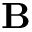Convert formula to latex. <formula><loc_0><loc_0><loc_500><loc_500>B</formula> 